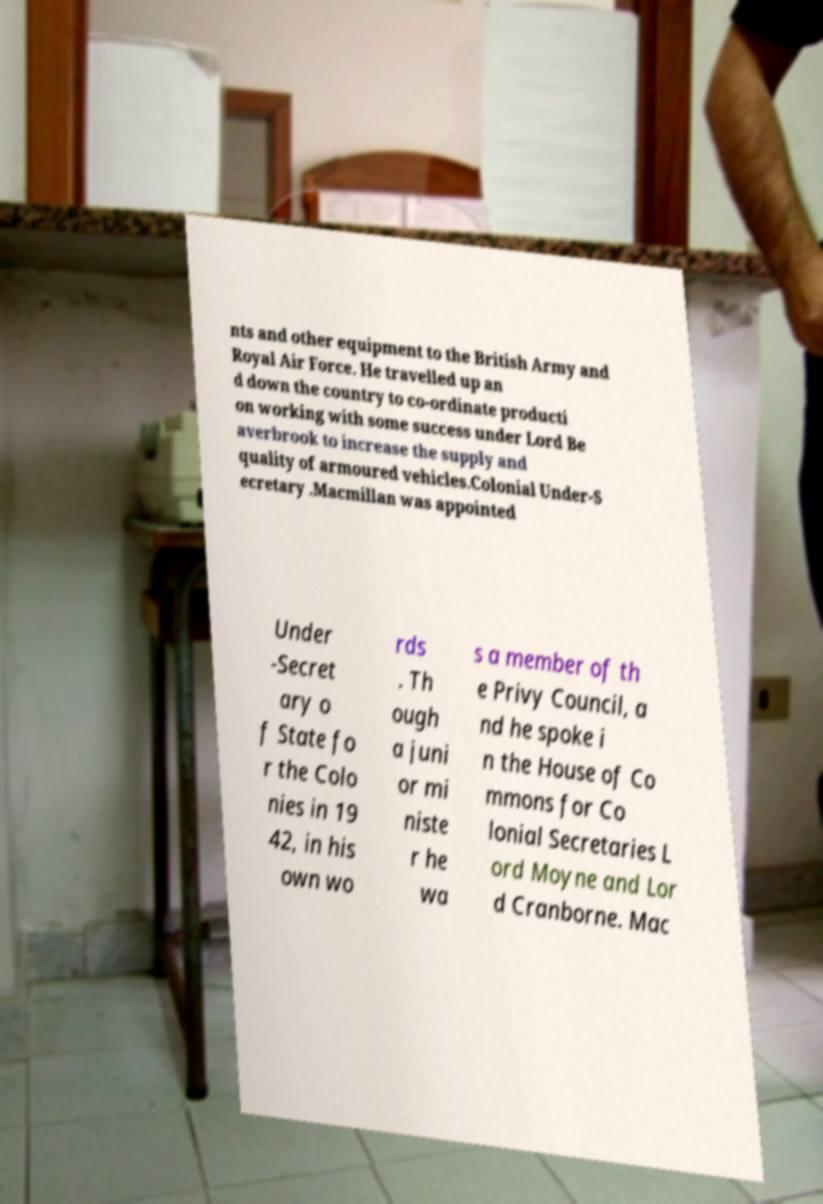There's text embedded in this image that I need extracted. Can you transcribe it verbatim? nts and other equipment to the British Army and Royal Air Force. He travelled up an d down the country to co-ordinate producti on working with some success under Lord Be averbrook to increase the supply and quality of armoured vehicles.Colonial Under-S ecretary .Macmillan was appointed Under -Secret ary o f State fo r the Colo nies in 19 42, in his own wo rds . Th ough a juni or mi niste r he wa s a member of th e Privy Council, a nd he spoke i n the House of Co mmons for Co lonial Secretaries L ord Moyne and Lor d Cranborne. Mac 